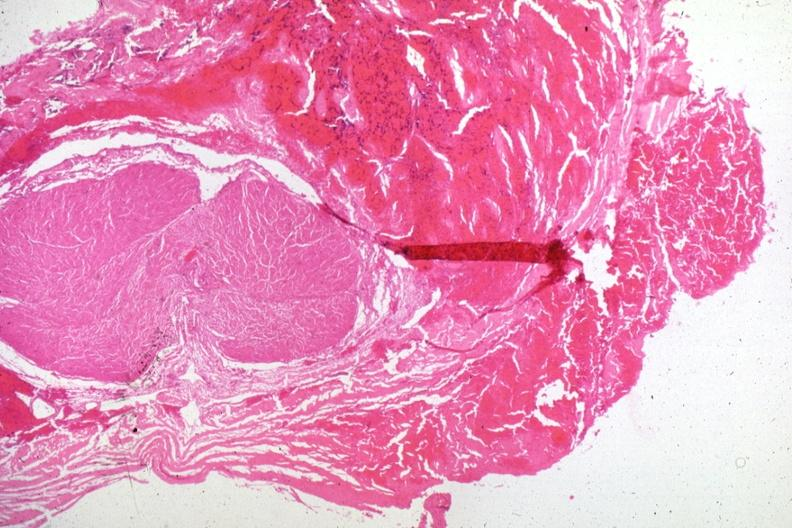s atheromatous embolus present?
Answer the question using a single word or phrase. No 